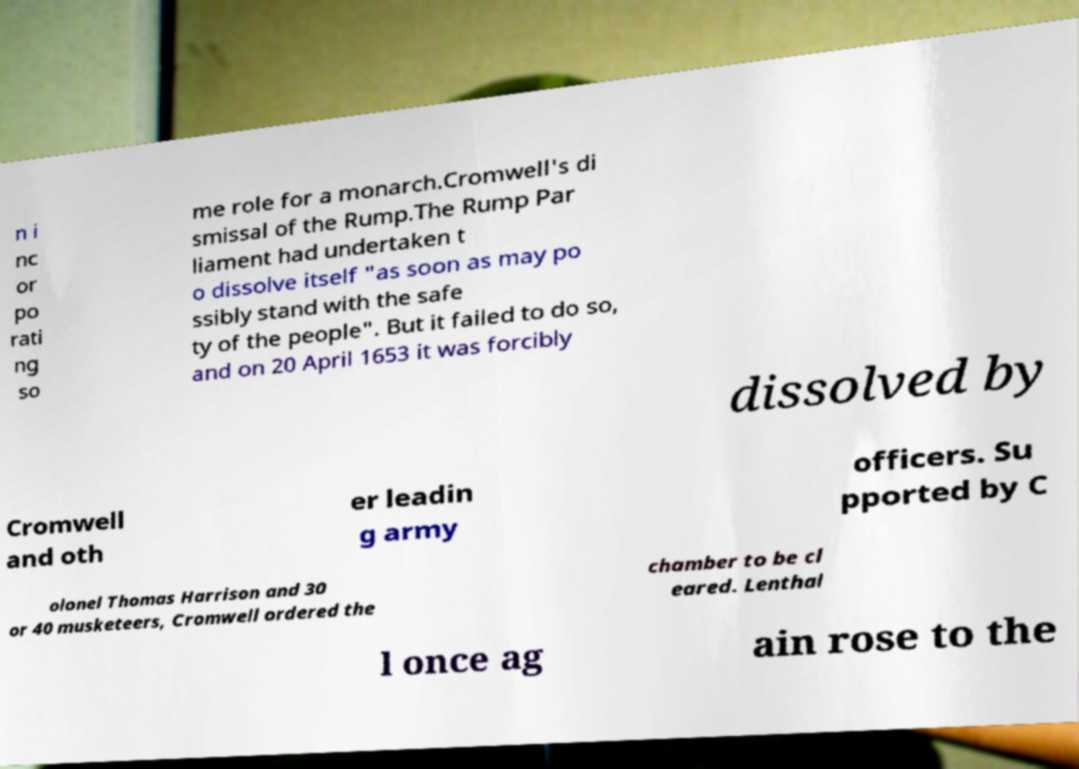Please read and relay the text visible in this image. What does it say? n i nc or po rati ng so me role for a monarch.Cromwell's di smissal of the Rump.The Rump Par liament had undertaken t o dissolve itself "as soon as may po ssibly stand with the safe ty of the people". But it failed to do so, and on 20 April 1653 it was forcibly dissolved by Cromwell and oth er leadin g army officers. Su pported by C olonel Thomas Harrison and 30 or 40 musketeers, Cromwell ordered the chamber to be cl eared. Lenthal l once ag ain rose to the 